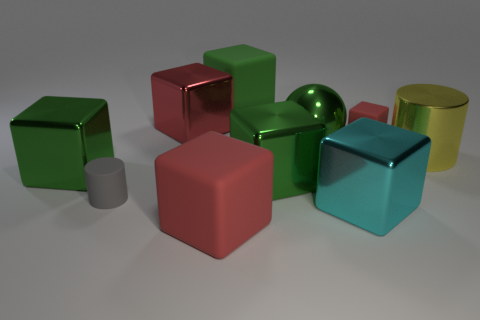How many green blocks must be subtracted to get 1 green blocks? 2 Subtract all gray cylinders. How many green cubes are left? 3 Subtract 4 blocks. How many blocks are left? 3 Subtract all green cubes. How many cubes are left? 4 Subtract all green metal cubes. How many cubes are left? 5 Subtract all blue spheres. Subtract all brown cubes. How many spheres are left? 1 Subtract all cylinders. How many objects are left? 8 Add 3 small cyan cylinders. How many small cyan cylinders exist? 3 Subtract 0 purple cubes. How many objects are left? 10 Subtract all matte blocks. Subtract all green shiny spheres. How many objects are left? 6 